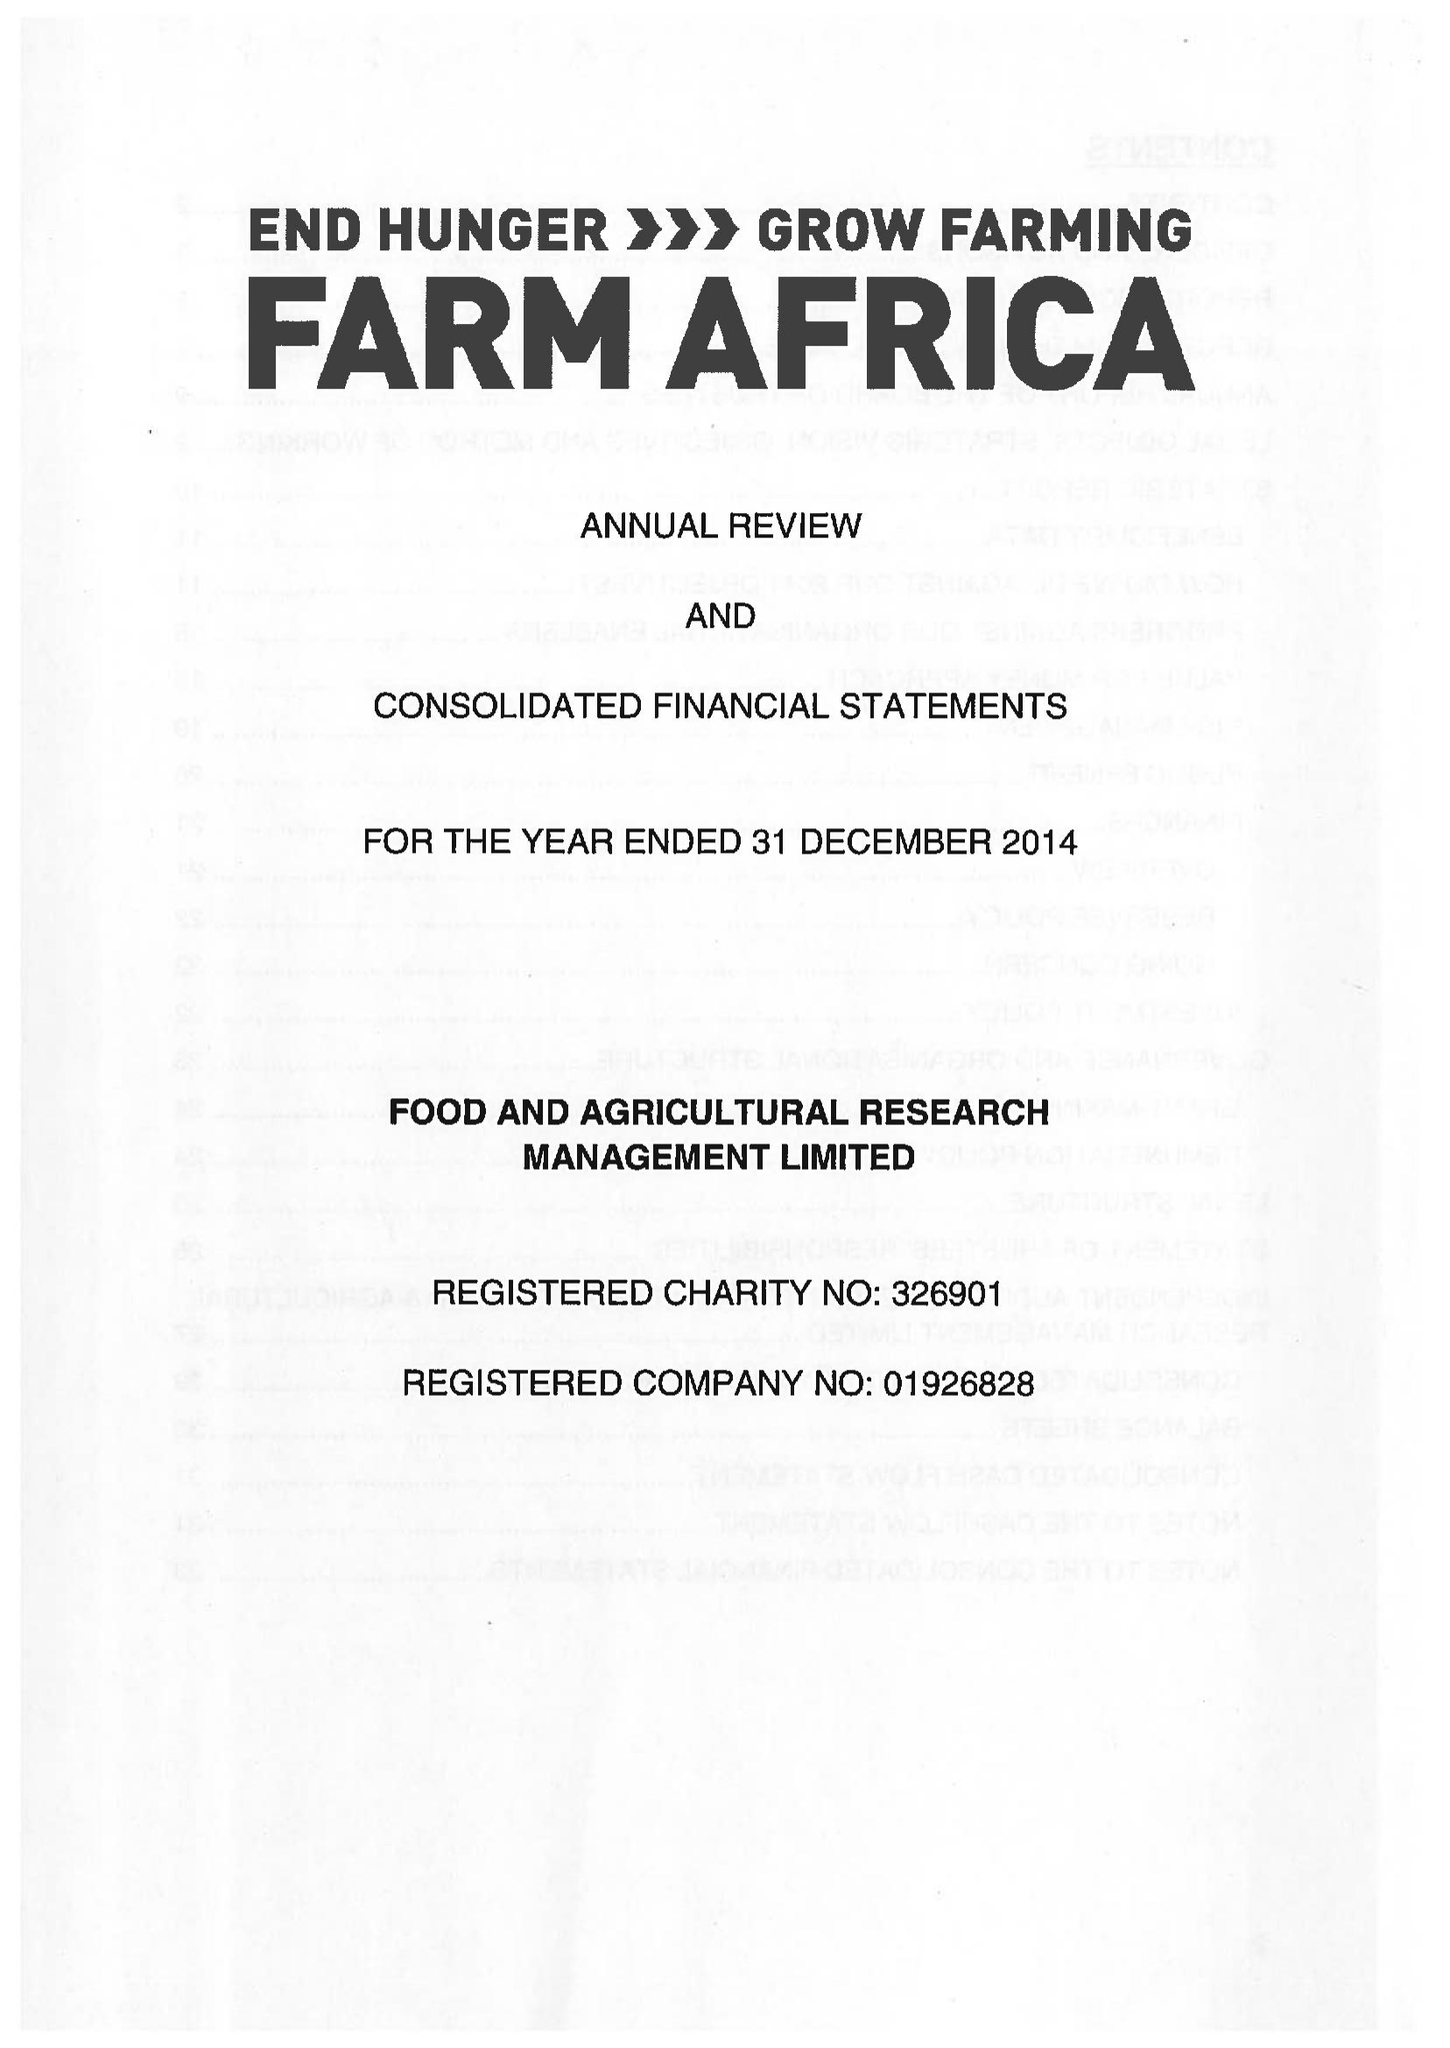What is the value for the spending_annually_in_british_pounds?
Answer the question using a single word or phrase. 12957000.00 